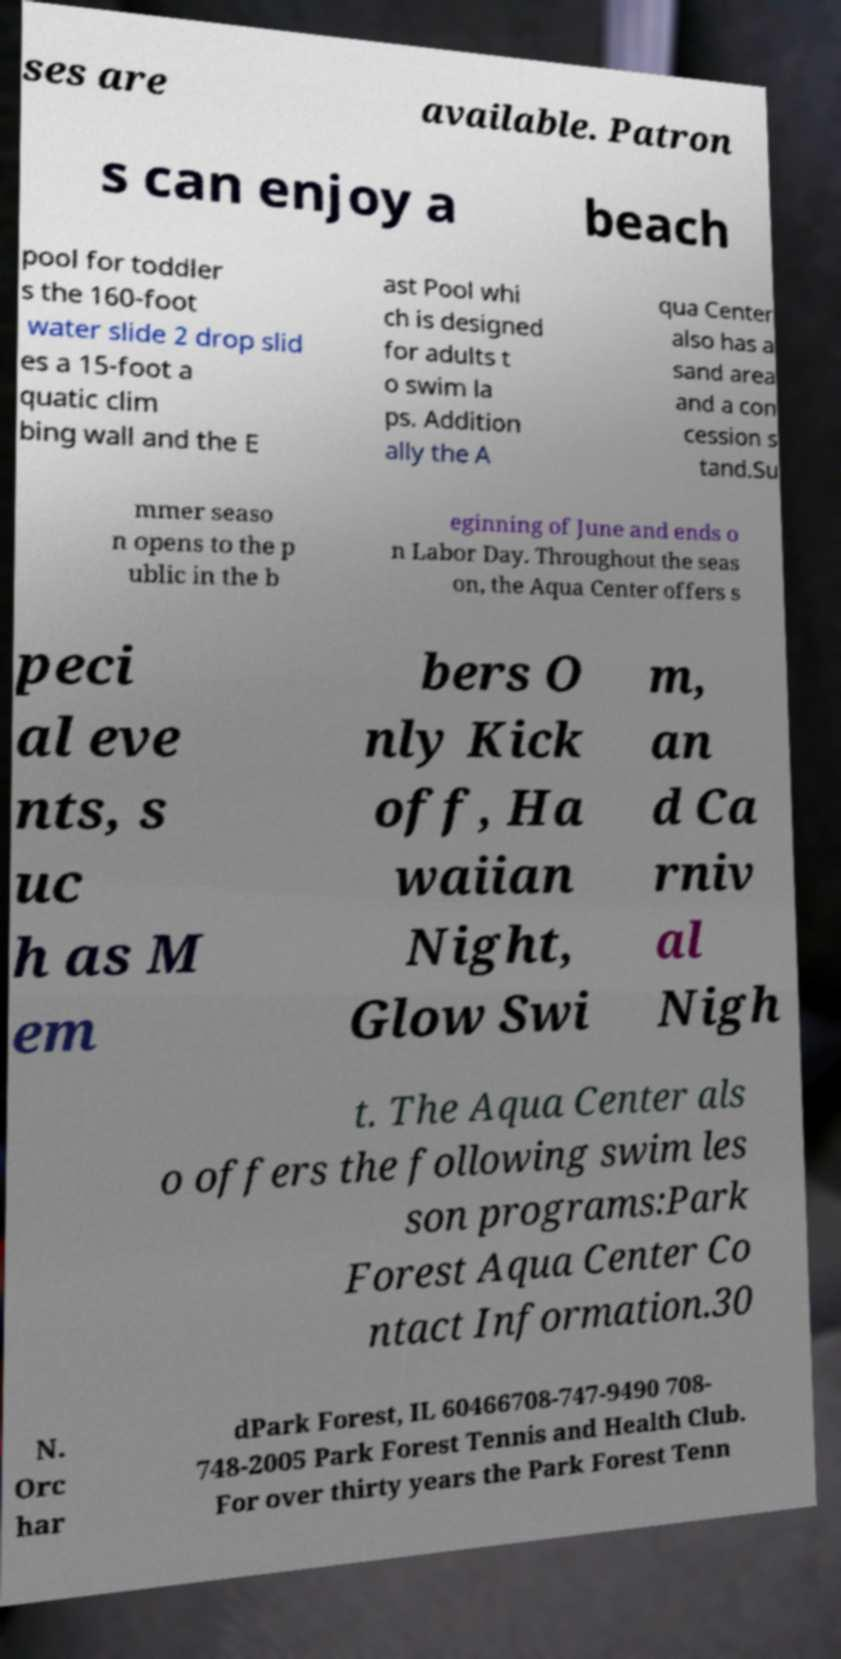What messages or text are displayed in this image? I need them in a readable, typed format. ses are available. Patron s can enjoy a beach pool for toddler s the 160-foot water slide 2 drop slid es a 15-foot a quatic clim bing wall and the E ast Pool whi ch is designed for adults t o swim la ps. Addition ally the A qua Center also has a sand area and a con cession s tand.Su mmer seaso n opens to the p ublic in the b eginning of June and ends o n Labor Day. Throughout the seas on, the Aqua Center offers s peci al eve nts, s uc h as M em bers O nly Kick off, Ha waiian Night, Glow Swi m, an d Ca rniv al Nigh t. The Aqua Center als o offers the following swim les son programs:Park Forest Aqua Center Co ntact Information.30 N. Orc har dPark Forest, IL 60466708-747-9490 708- 748-2005 Park Forest Tennis and Health Club. For over thirty years the Park Forest Tenn 